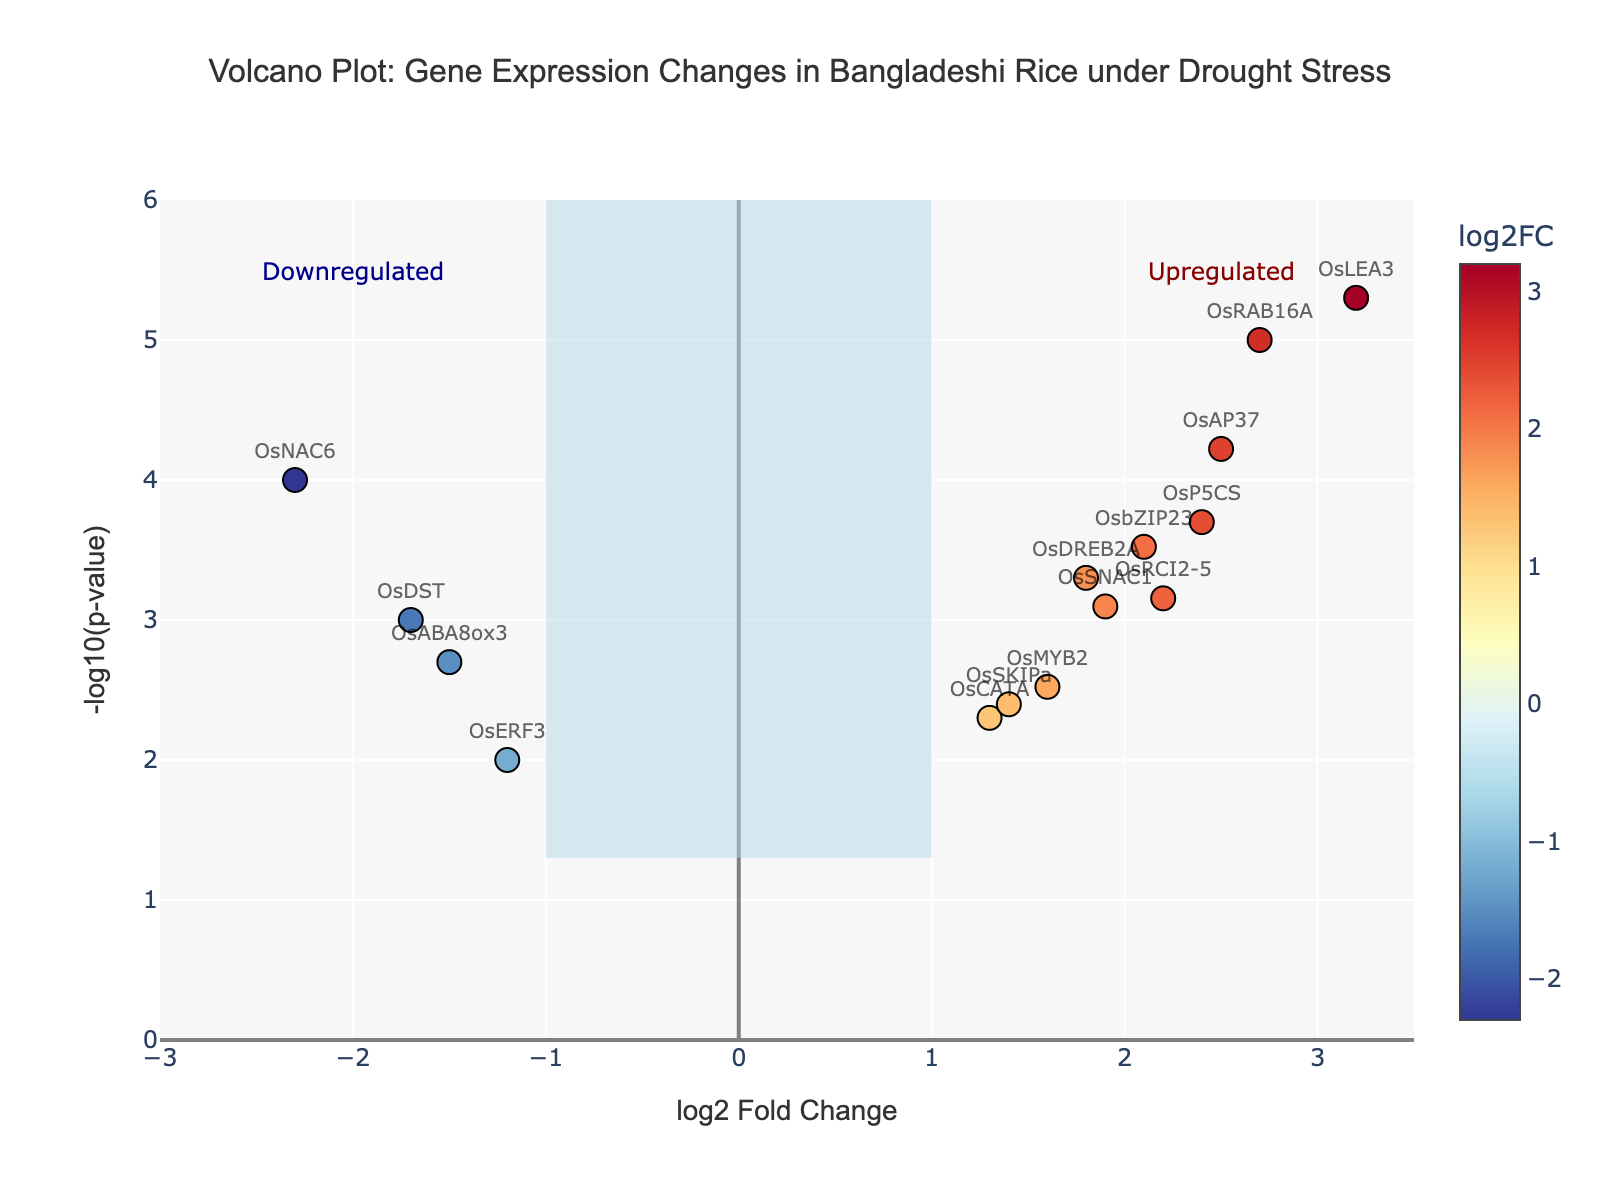Which gene has the highest -log10(p-value)? To identify the gene with the highest -log10(p-value), we look for the data point that appears at the highest position on the y-axis. By checking the plot, we find that the gene OsLEA3 has the highest -log10(p-value).
Answer: OsLEA3 How many genes are upregulated? Upregulated genes have positive log2 fold change values. By counting the data points on the right side of the vertical line at log2 fold change = 1, we find that there are 9 such genes.
Answer: 9 Which gene has the most significant downregulation under drought stress? The most significantly downregulated gene will have the highest -log10(p-value) and a negative log2 fold change. Checking the data points with negative log2 fold changes, OsNAC6 has the lowest fold change and also one of the highest -log10(p-values).
Answer: OsNAC6 Which gene has the smallest p-value? The smallest p-value corresponds to the highest -log10(p-value). Checking the highest positioned data point on the plot, OsLEA3 has the smallest p-value.
Answer: OsLEA3 What is the log2 fold change of OsRAB16A? To find the log2 fold change for OsRAB16A, locate the point labeled OsRAB16A. From the plot, OsRAB16A is at log2 fold change around 2.7.
Answer: 2.7 How many genes have a p-value less than 0.01? A p-value less than 0.01 corresponds to a -log10(p-value) greater than 2. By counting the data points above the horizontal line marked at -log10(p-value) = 2, we find that there are 8 data points.
Answer: 8 Which two genes have a similar -log10(p-value) close to 3.3? To find genes with a -log10(p-value) close to 3.3, we check around y=3.3 on the plot. Both OsP5CS and OsAP37 are located around this area.
Answer: OsP5CS and OsAP37 Are there more genes upregulated or downregulated under drought stress? Compare the counts of upregulated (right side of the vertical line at log2 fold change = 1) and downregulated (left side of the vertical line at log2 fold change = -1) genes. From the plot, there are more upregulated genes.
Answer: Upregulated Which gene shows moderate upregulation and a significant p-value of less than 0.01? To find a gene with moderate upregulation (log2 fold change around 1.5 - 2.0) and a significant p-value (below -log10(p-value) = 2), we check the plot and identify OsDREB2A.
Answer: OsDREB2A 